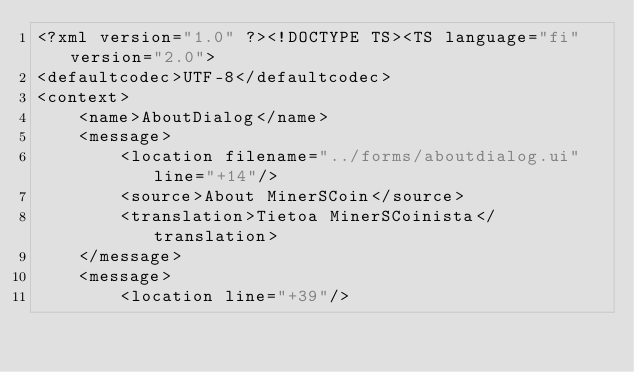<code> <loc_0><loc_0><loc_500><loc_500><_TypeScript_><?xml version="1.0" ?><!DOCTYPE TS><TS language="fi" version="2.0">
<defaultcodec>UTF-8</defaultcodec>
<context>
    <name>AboutDialog</name>
    <message>
        <location filename="../forms/aboutdialog.ui" line="+14"/>
        <source>About MinerSCoin</source>
        <translation>Tietoa MinerSCoinista</translation>
    </message>
    <message>
        <location line="+39"/></code> 